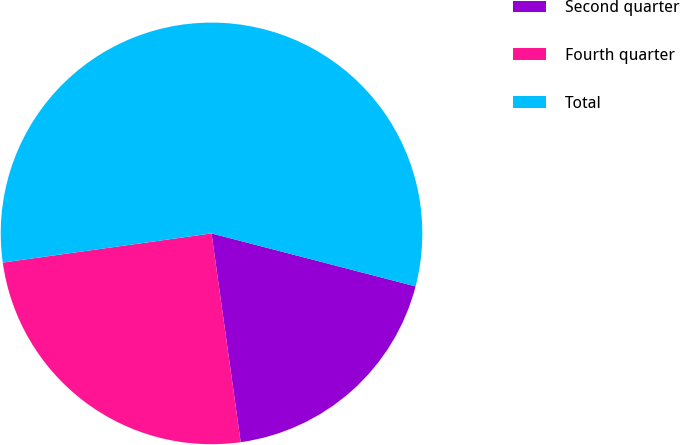Convert chart to OTSL. <chart><loc_0><loc_0><loc_500><loc_500><pie_chart><fcel>Second quarter<fcel>Fourth quarter<fcel>Total<nl><fcel>18.75%<fcel>25.0%<fcel>56.25%<nl></chart> 